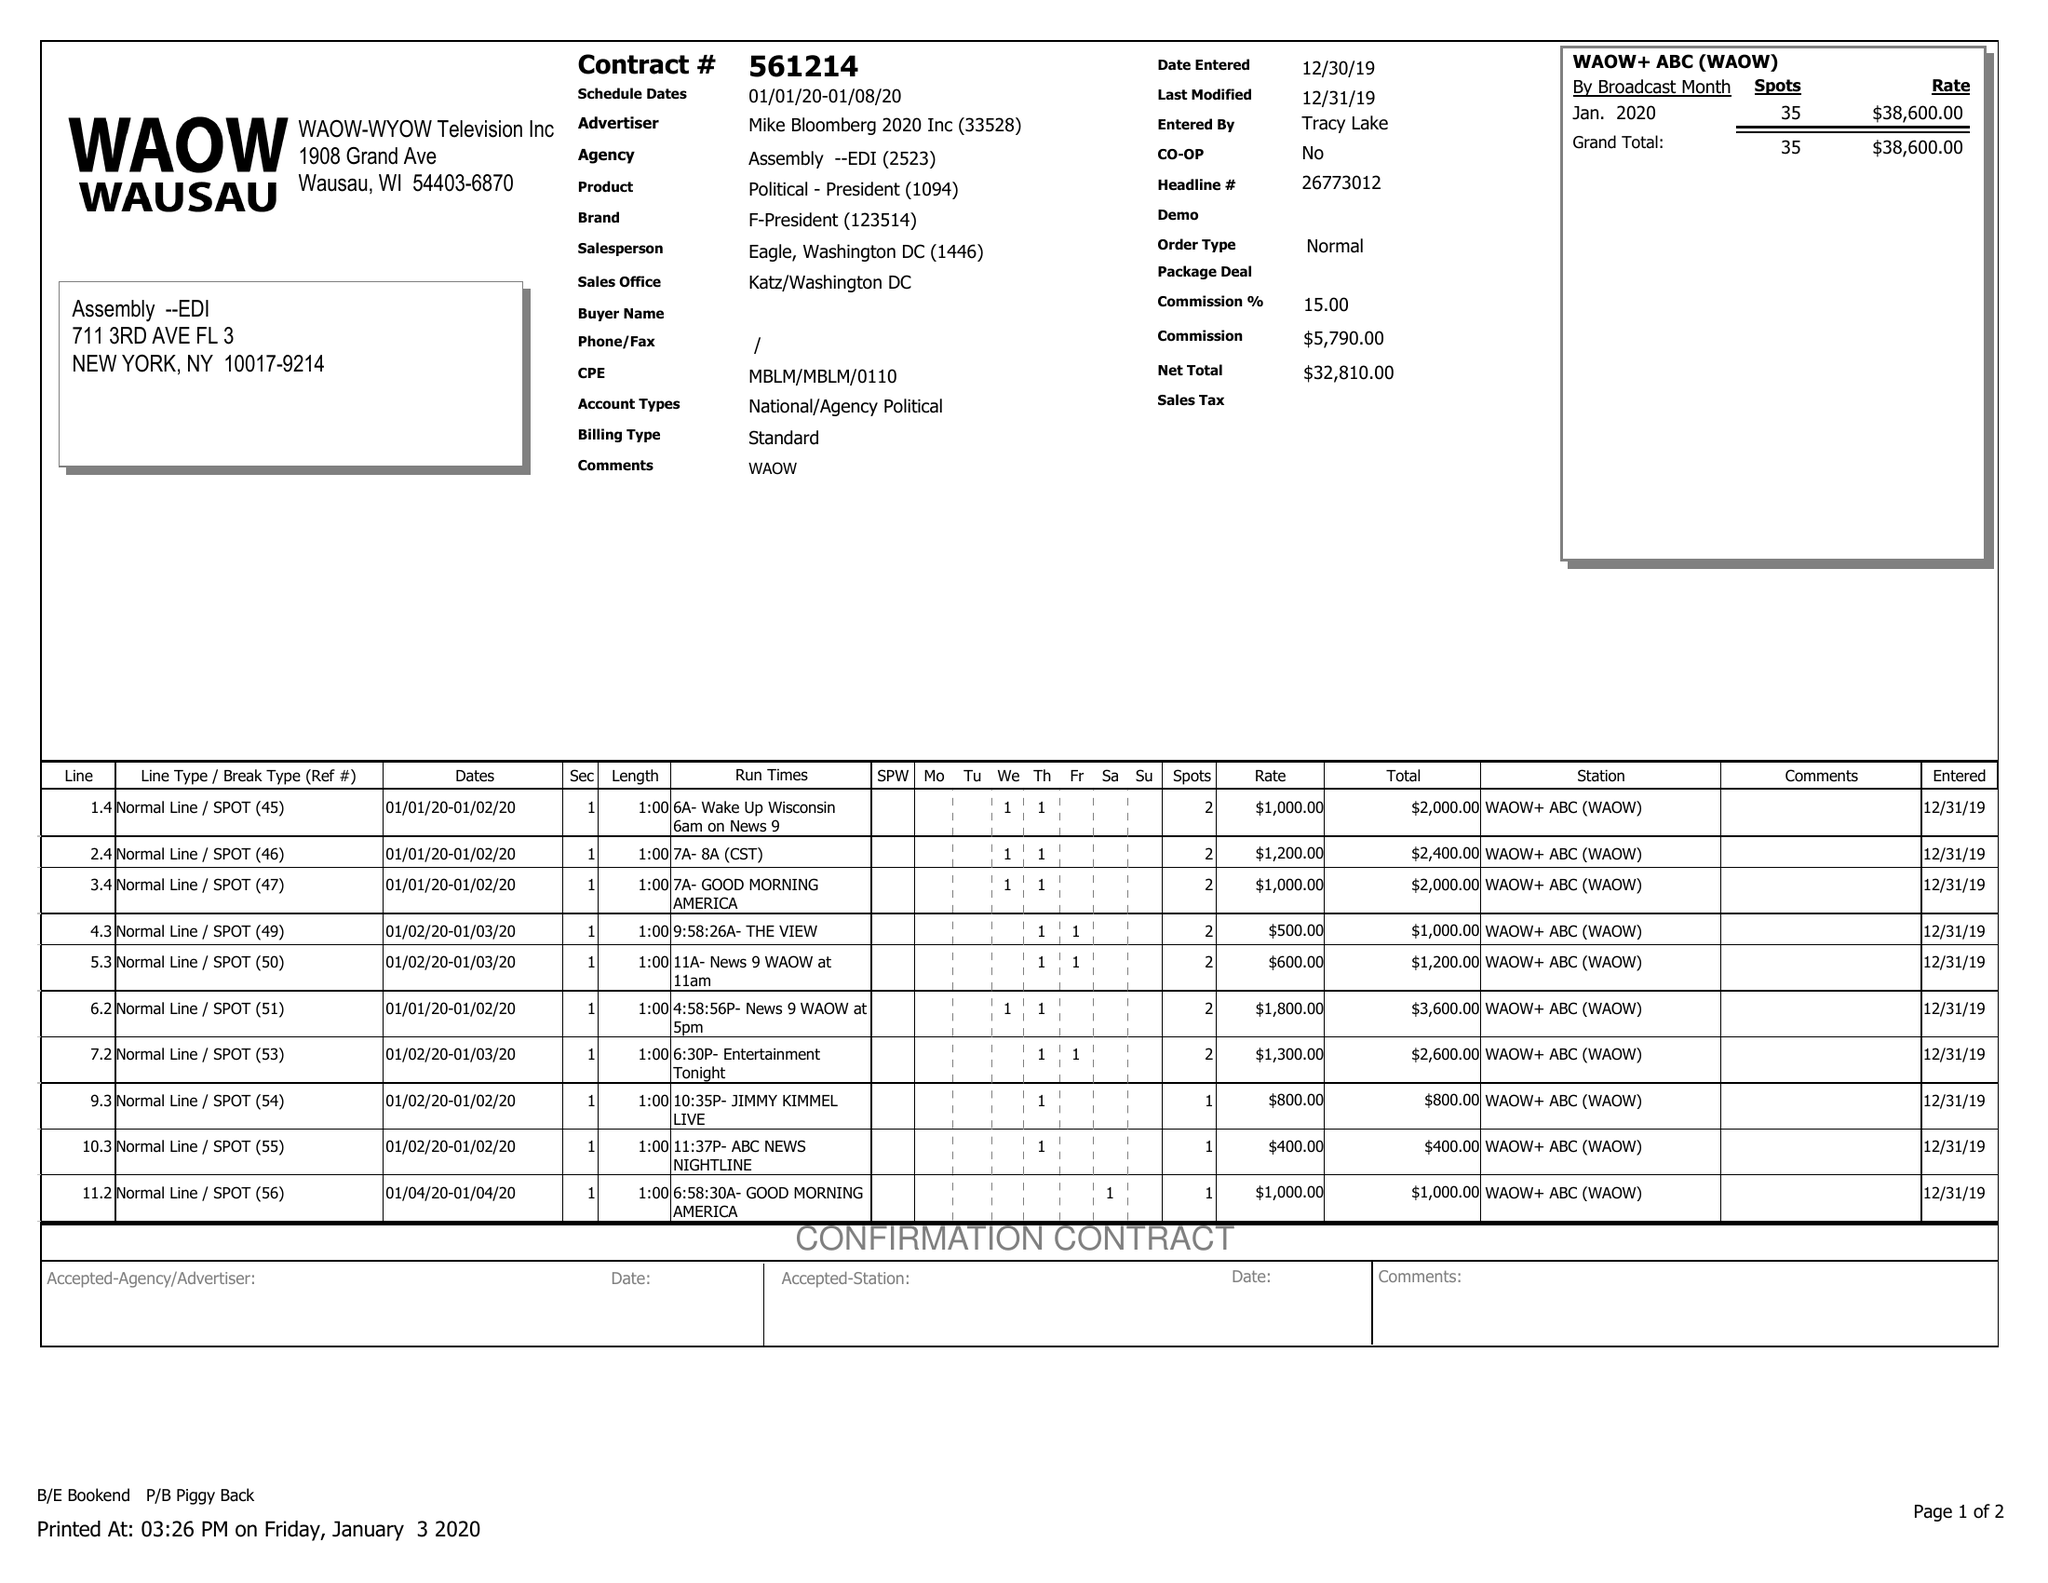What is the value for the gross_amount?
Answer the question using a single word or phrase. 38600.00 